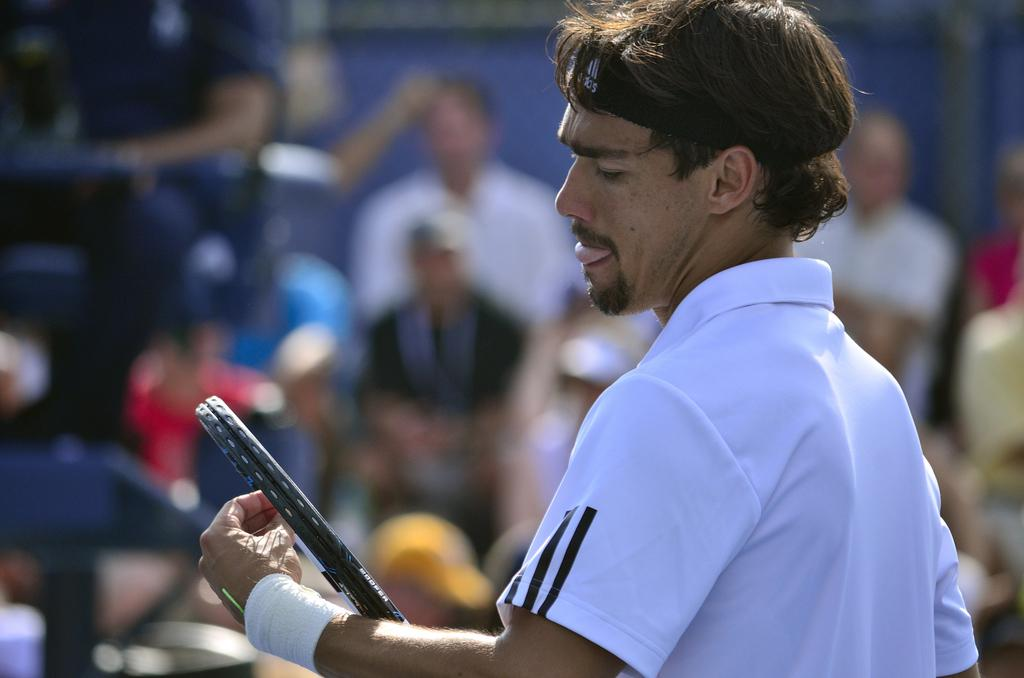What is the person in the image wearing? The person is wearing a white dress. What object is the person holding in the image? The person is holding a tennis racket. What accessory is the person wearing on their wrist? The person is wearing a wrist band. Can you describe the people in the background of the image? There are people sitting in the background of the image. Where is the nest located in the image? There is no nest present in the image. Who is the manager of the tennis team in the image? There is no mention of a tennis team or a manager in the image. 